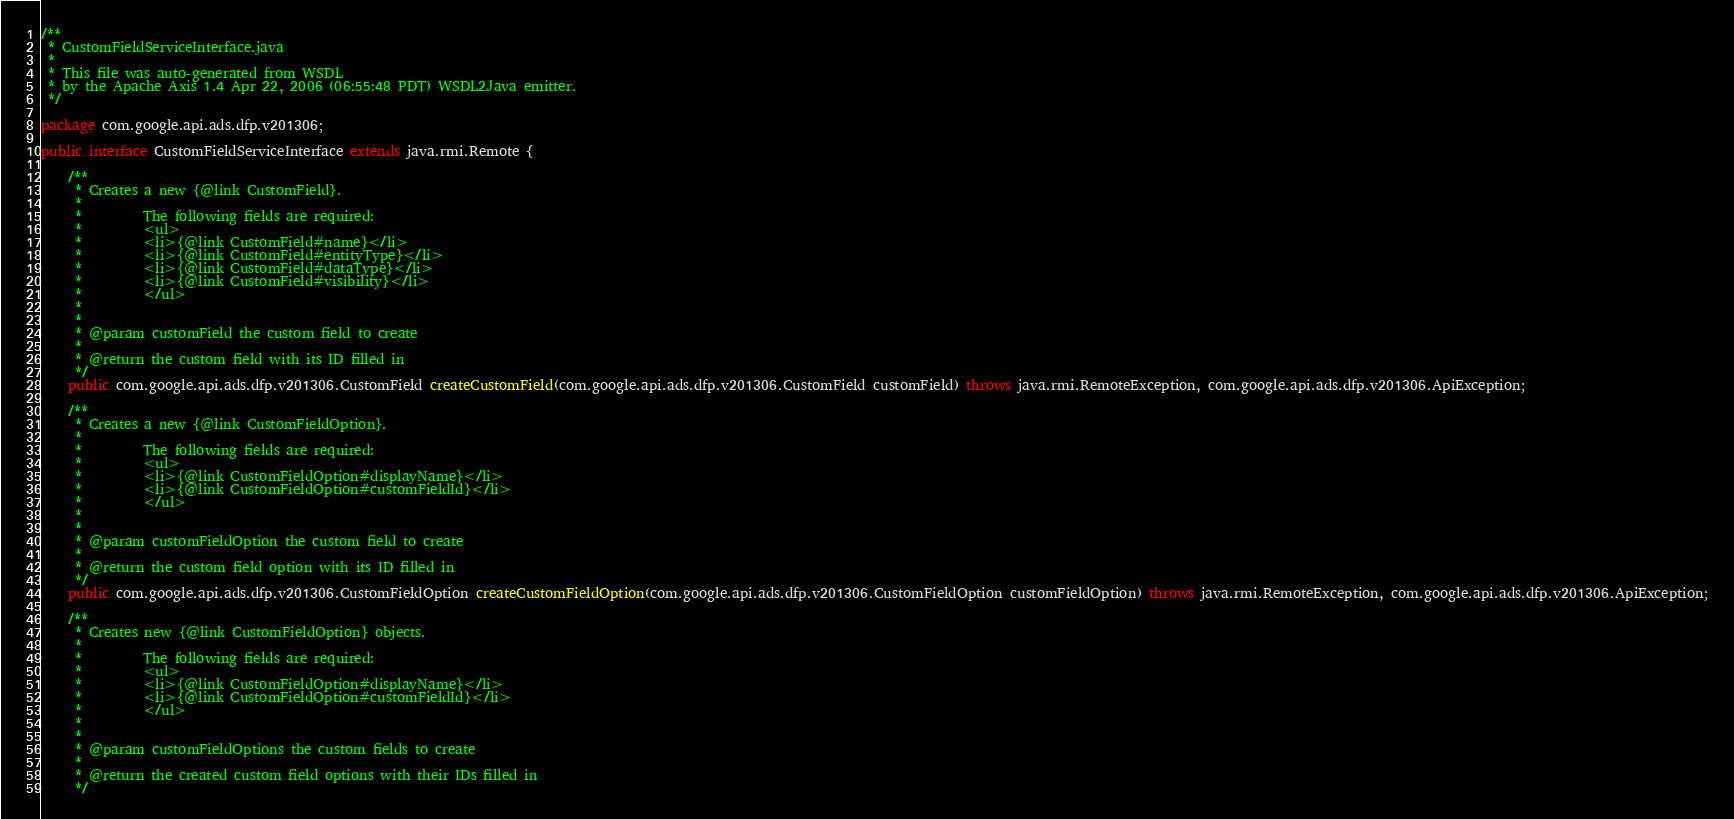<code> <loc_0><loc_0><loc_500><loc_500><_Java_>/**
 * CustomFieldServiceInterface.java
 *
 * This file was auto-generated from WSDL
 * by the Apache Axis 1.4 Apr 22, 2006 (06:55:48 PDT) WSDL2Java emitter.
 */

package com.google.api.ads.dfp.v201306;

public interface CustomFieldServiceInterface extends java.rmi.Remote {

    /**
     * Creates a new {@link CustomField}.
     *         
     *         The following fields are required:
     *         <ul>
     *         <li>{@link CustomField#name}</li>
     *         <li>{@link CustomField#entityType}</li>
     *         <li>{@link CustomField#dataType}</li>
     *         <li>{@link CustomField#visibility}</li>
     *         </ul>
     *         
     *         
     * @param customField the custom field to create
     *         
     * @return the custom field with its ID filled in
     */
    public com.google.api.ads.dfp.v201306.CustomField createCustomField(com.google.api.ads.dfp.v201306.CustomField customField) throws java.rmi.RemoteException, com.google.api.ads.dfp.v201306.ApiException;

    /**
     * Creates a new {@link CustomFieldOption}.
     *         
     *         The following fields are required:
     *         <ul>
     *         <li>{@link CustomFieldOption#displayName}</li>
     *         <li>{@link CustomFieldOption#customFieldId}</li>
     *         </ul>
     *         
     *         
     * @param customFieldOption the custom field to create
     *         
     * @return the custom field option with its ID filled in
     */
    public com.google.api.ads.dfp.v201306.CustomFieldOption createCustomFieldOption(com.google.api.ads.dfp.v201306.CustomFieldOption customFieldOption) throws java.rmi.RemoteException, com.google.api.ads.dfp.v201306.ApiException;

    /**
     * Creates new {@link CustomFieldOption} objects.
     *         
     *         The following fields are required:
     *         <ul>
     *         <li>{@link CustomFieldOption#displayName}</li>
     *         <li>{@link CustomFieldOption#customFieldId}</li>
     *         </ul>
     *         
     *         
     * @param customFieldOptions the custom fields to create
     *         
     * @return the created custom field options with their IDs filled in
     */</code> 